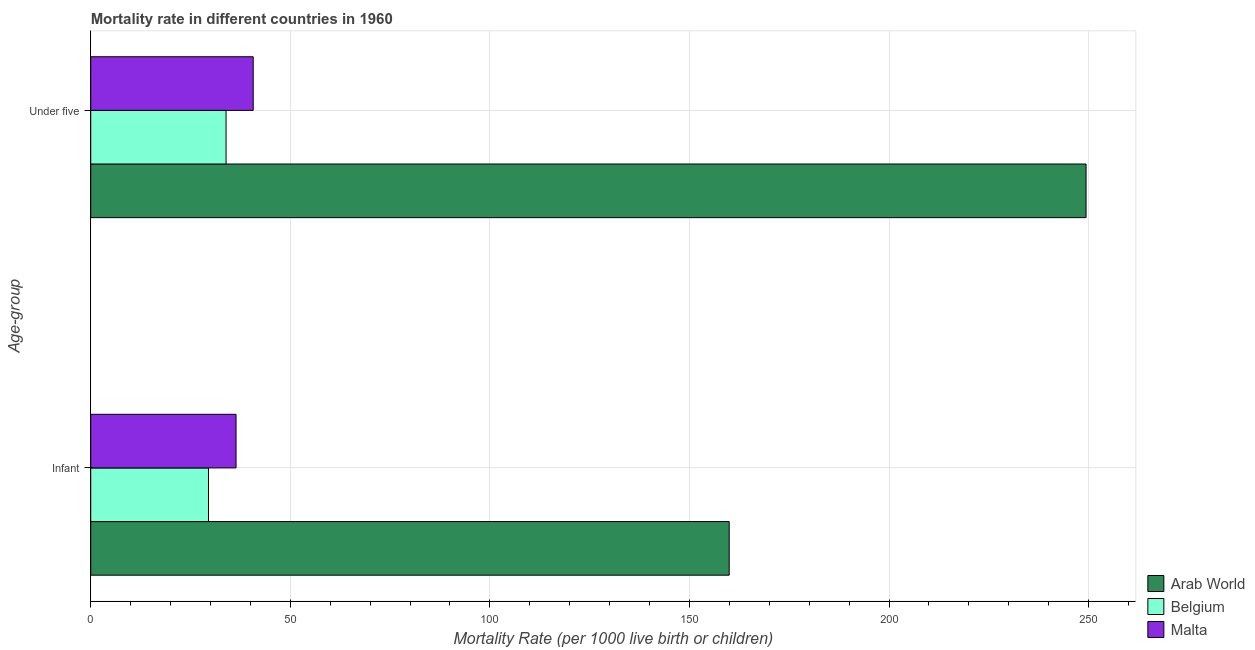How many different coloured bars are there?
Keep it short and to the point. 3. How many bars are there on the 2nd tick from the top?
Provide a short and direct response. 3. How many bars are there on the 2nd tick from the bottom?
Your answer should be very brief. 3. What is the label of the 1st group of bars from the top?
Keep it short and to the point. Under five. What is the under-5 mortality rate in Arab World?
Provide a succinct answer. 249.36. Across all countries, what is the maximum infant mortality rate?
Offer a very short reply. 159.95. Across all countries, what is the minimum under-5 mortality rate?
Offer a terse response. 33.9. In which country was the infant mortality rate maximum?
Provide a short and direct response. Arab World. In which country was the infant mortality rate minimum?
Keep it short and to the point. Belgium. What is the total under-5 mortality rate in the graph?
Offer a terse response. 323.96. What is the difference between the under-5 mortality rate in Arab World and that in Malta?
Keep it short and to the point. 208.66. What is the difference between the under-5 mortality rate in Arab World and the infant mortality rate in Malta?
Provide a short and direct response. 212.96. What is the average under-5 mortality rate per country?
Give a very brief answer. 107.99. What is the difference between the under-5 mortality rate and infant mortality rate in Belgium?
Offer a terse response. 4.4. What is the ratio of the infant mortality rate in Malta to that in Arab World?
Keep it short and to the point. 0.23. Is the under-5 mortality rate in Belgium less than that in Malta?
Your answer should be very brief. Yes. In how many countries, is the under-5 mortality rate greater than the average under-5 mortality rate taken over all countries?
Provide a succinct answer. 1. What does the 3rd bar from the top in Infant represents?
Ensure brevity in your answer.  Arab World. What does the 2nd bar from the bottom in Under five represents?
Provide a succinct answer. Belgium. How many bars are there?
Your response must be concise. 6. What is the difference between two consecutive major ticks on the X-axis?
Offer a very short reply. 50. Are the values on the major ticks of X-axis written in scientific E-notation?
Provide a short and direct response. No. Does the graph contain grids?
Provide a short and direct response. Yes. What is the title of the graph?
Offer a terse response. Mortality rate in different countries in 1960. What is the label or title of the X-axis?
Ensure brevity in your answer.  Mortality Rate (per 1000 live birth or children). What is the label or title of the Y-axis?
Offer a very short reply. Age-group. What is the Mortality Rate (per 1000 live birth or children) in Arab World in Infant?
Provide a succinct answer. 159.95. What is the Mortality Rate (per 1000 live birth or children) of Belgium in Infant?
Offer a terse response. 29.5. What is the Mortality Rate (per 1000 live birth or children) of Malta in Infant?
Your answer should be very brief. 36.4. What is the Mortality Rate (per 1000 live birth or children) of Arab World in Under five?
Your response must be concise. 249.36. What is the Mortality Rate (per 1000 live birth or children) of Belgium in Under five?
Your answer should be compact. 33.9. What is the Mortality Rate (per 1000 live birth or children) in Malta in Under five?
Your answer should be very brief. 40.7. Across all Age-group, what is the maximum Mortality Rate (per 1000 live birth or children) in Arab World?
Offer a terse response. 249.36. Across all Age-group, what is the maximum Mortality Rate (per 1000 live birth or children) of Belgium?
Offer a terse response. 33.9. Across all Age-group, what is the maximum Mortality Rate (per 1000 live birth or children) in Malta?
Provide a succinct answer. 40.7. Across all Age-group, what is the minimum Mortality Rate (per 1000 live birth or children) in Arab World?
Keep it short and to the point. 159.95. Across all Age-group, what is the minimum Mortality Rate (per 1000 live birth or children) of Belgium?
Your answer should be compact. 29.5. Across all Age-group, what is the minimum Mortality Rate (per 1000 live birth or children) in Malta?
Your answer should be compact. 36.4. What is the total Mortality Rate (per 1000 live birth or children) of Arab World in the graph?
Provide a succinct answer. 409.31. What is the total Mortality Rate (per 1000 live birth or children) in Belgium in the graph?
Your response must be concise. 63.4. What is the total Mortality Rate (per 1000 live birth or children) in Malta in the graph?
Provide a short and direct response. 77.1. What is the difference between the Mortality Rate (per 1000 live birth or children) in Arab World in Infant and that in Under five?
Ensure brevity in your answer.  -89.41. What is the difference between the Mortality Rate (per 1000 live birth or children) in Belgium in Infant and that in Under five?
Your answer should be very brief. -4.4. What is the difference between the Mortality Rate (per 1000 live birth or children) in Arab World in Infant and the Mortality Rate (per 1000 live birth or children) in Belgium in Under five?
Offer a terse response. 126.05. What is the difference between the Mortality Rate (per 1000 live birth or children) in Arab World in Infant and the Mortality Rate (per 1000 live birth or children) in Malta in Under five?
Your answer should be very brief. 119.25. What is the average Mortality Rate (per 1000 live birth or children) of Arab World per Age-group?
Your response must be concise. 204.66. What is the average Mortality Rate (per 1000 live birth or children) of Belgium per Age-group?
Make the answer very short. 31.7. What is the average Mortality Rate (per 1000 live birth or children) of Malta per Age-group?
Your answer should be compact. 38.55. What is the difference between the Mortality Rate (per 1000 live birth or children) in Arab World and Mortality Rate (per 1000 live birth or children) in Belgium in Infant?
Provide a succinct answer. 130.45. What is the difference between the Mortality Rate (per 1000 live birth or children) in Arab World and Mortality Rate (per 1000 live birth or children) in Malta in Infant?
Your response must be concise. 123.55. What is the difference between the Mortality Rate (per 1000 live birth or children) of Arab World and Mortality Rate (per 1000 live birth or children) of Belgium in Under five?
Ensure brevity in your answer.  215.46. What is the difference between the Mortality Rate (per 1000 live birth or children) of Arab World and Mortality Rate (per 1000 live birth or children) of Malta in Under five?
Give a very brief answer. 208.66. What is the ratio of the Mortality Rate (per 1000 live birth or children) in Arab World in Infant to that in Under five?
Ensure brevity in your answer.  0.64. What is the ratio of the Mortality Rate (per 1000 live birth or children) of Belgium in Infant to that in Under five?
Give a very brief answer. 0.87. What is the ratio of the Mortality Rate (per 1000 live birth or children) of Malta in Infant to that in Under five?
Provide a succinct answer. 0.89. What is the difference between the highest and the second highest Mortality Rate (per 1000 live birth or children) of Arab World?
Keep it short and to the point. 89.41. What is the difference between the highest and the lowest Mortality Rate (per 1000 live birth or children) of Arab World?
Offer a very short reply. 89.41. What is the difference between the highest and the lowest Mortality Rate (per 1000 live birth or children) of Belgium?
Provide a succinct answer. 4.4. What is the difference between the highest and the lowest Mortality Rate (per 1000 live birth or children) in Malta?
Provide a short and direct response. 4.3. 